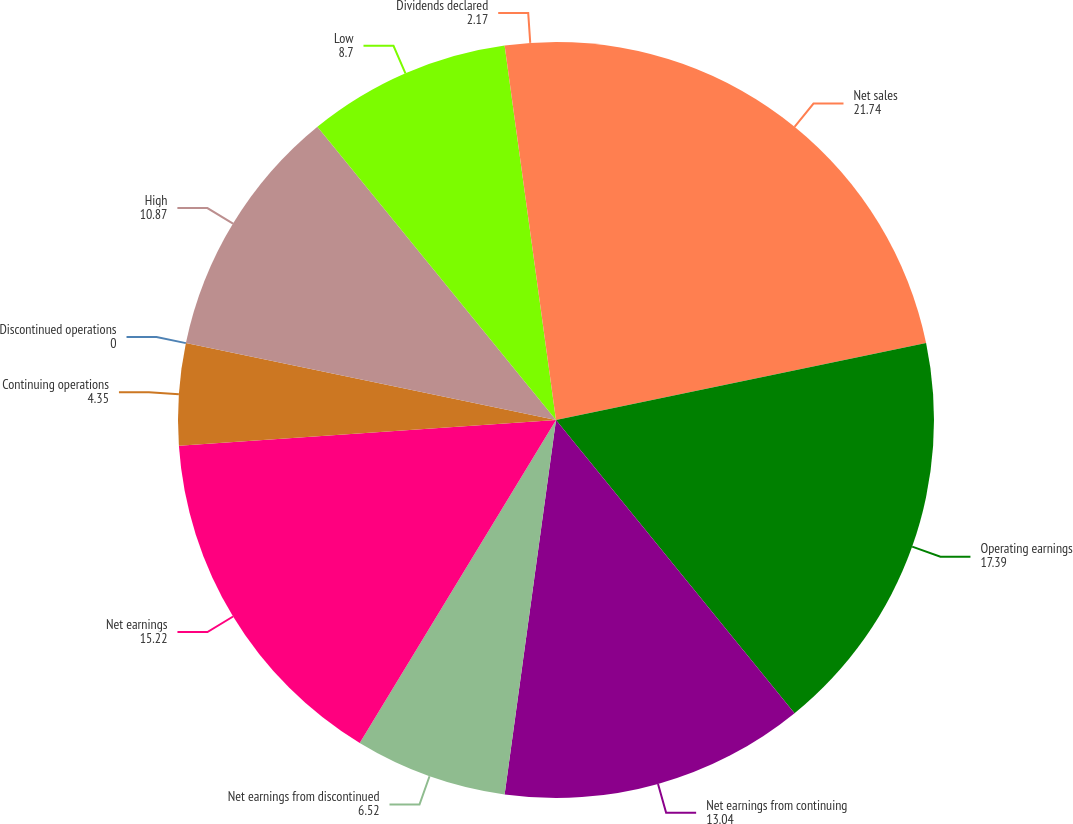<chart> <loc_0><loc_0><loc_500><loc_500><pie_chart><fcel>Net sales<fcel>Operating earnings<fcel>Net earnings from continuing<fcel>Net earnings from discontinued<fcel>Net earnings<fcel>Continuing operations<fcel>Discontinued operations<fcel>High<fcel>Low<fcel>Dividends declared<nl><fcel>21.74%<fcel>17.39%<fcel>13.04%<fcel>6.52%<fcel>15.22%<fcel>4.35%<fcel>0.0%<fcel>10.87%<fcel>8.7%<fcel>2.17%<nl></chart> 